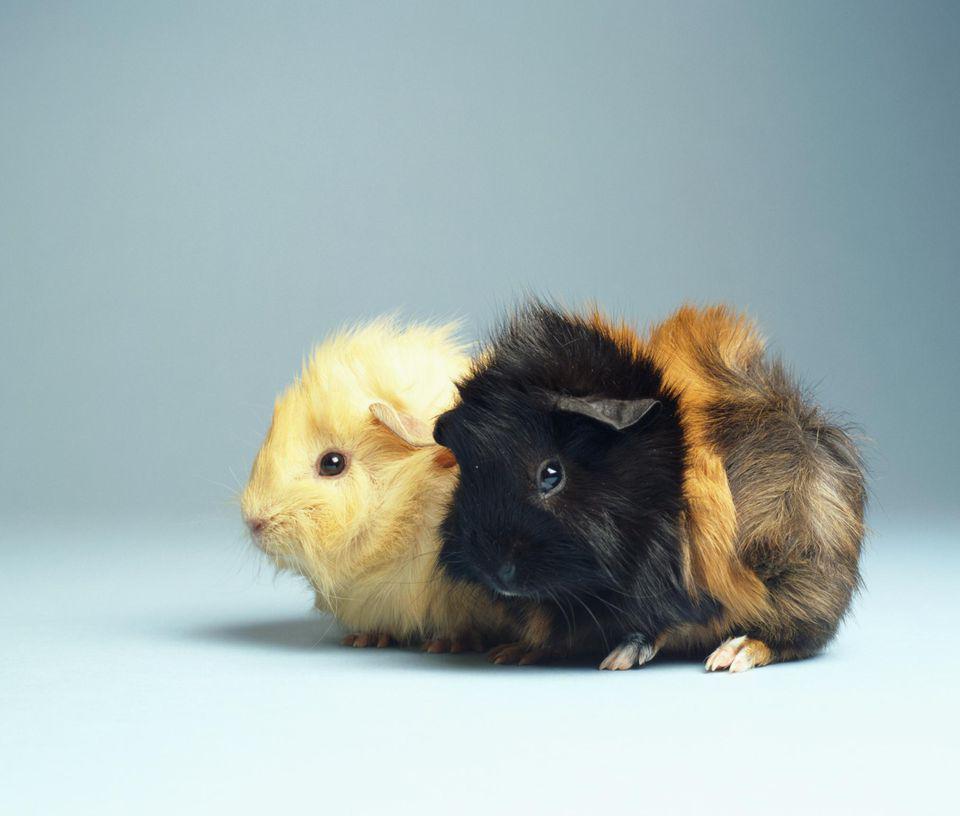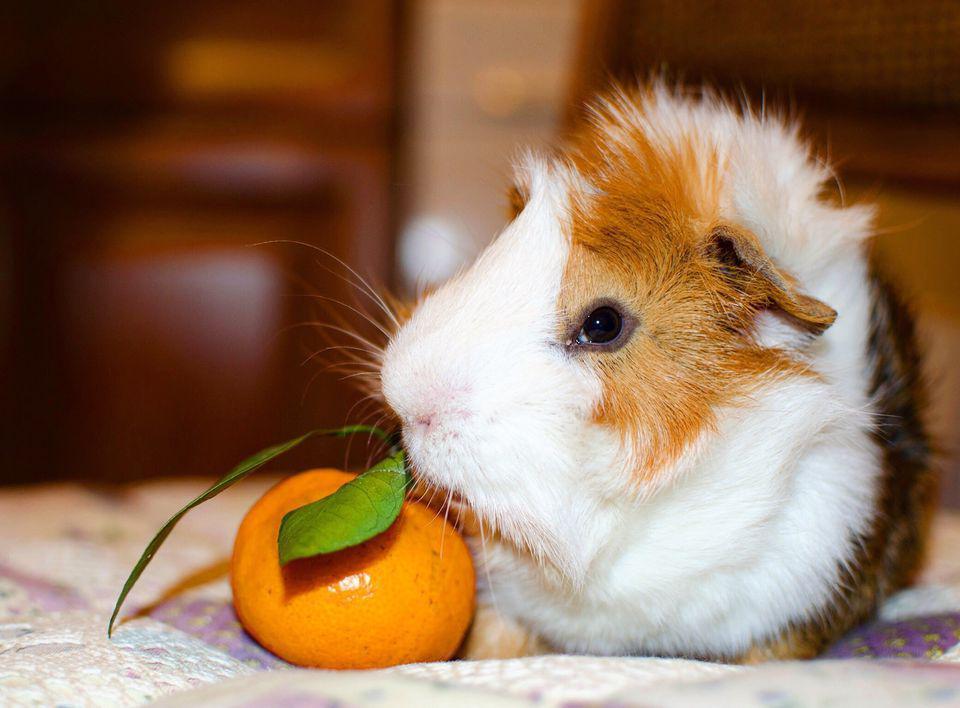The first image is the image on the left, the second image is the image on the right. Assess this claim about the two images: "Each image contains the same number of guinea pigs, and all animals share similar poses.". Correct or not? Answer yes or no. No. 